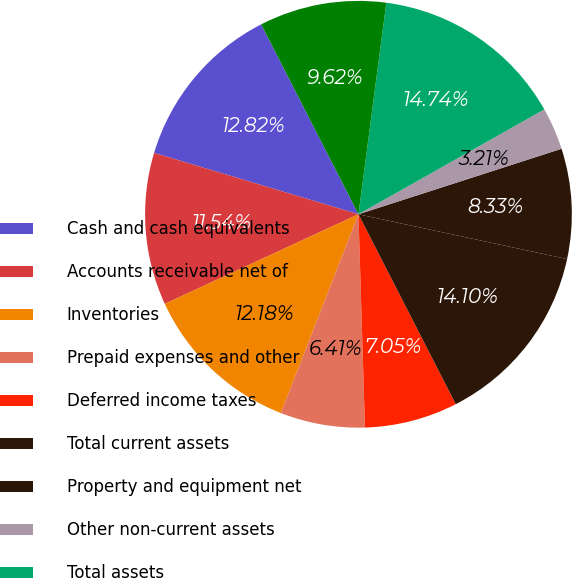Convert chart. <chart><loc_0><loc_0><loc_500><loc_500><pie_chart><fcel>Cash and cash equivalents<fcel>Accounts receivable net of<fcel>Inventories<fcel>Prepaid expenses and other<fcel>Deferred income taxes<fcel>Total current assets<fcel>Property and equipment net<fcel>Other non-current assets<fcel>Total assets<fcel>Accounts payable<nl><fcel>12.82%<fcel>11.54%<fcel>12.18%<fcel>6.41%<fcel>7.05%<fcel>14.1%<fcel>8.33%<fcel>3.21%<fcel>14.74%<fcel>9.62%<nl></chart> 